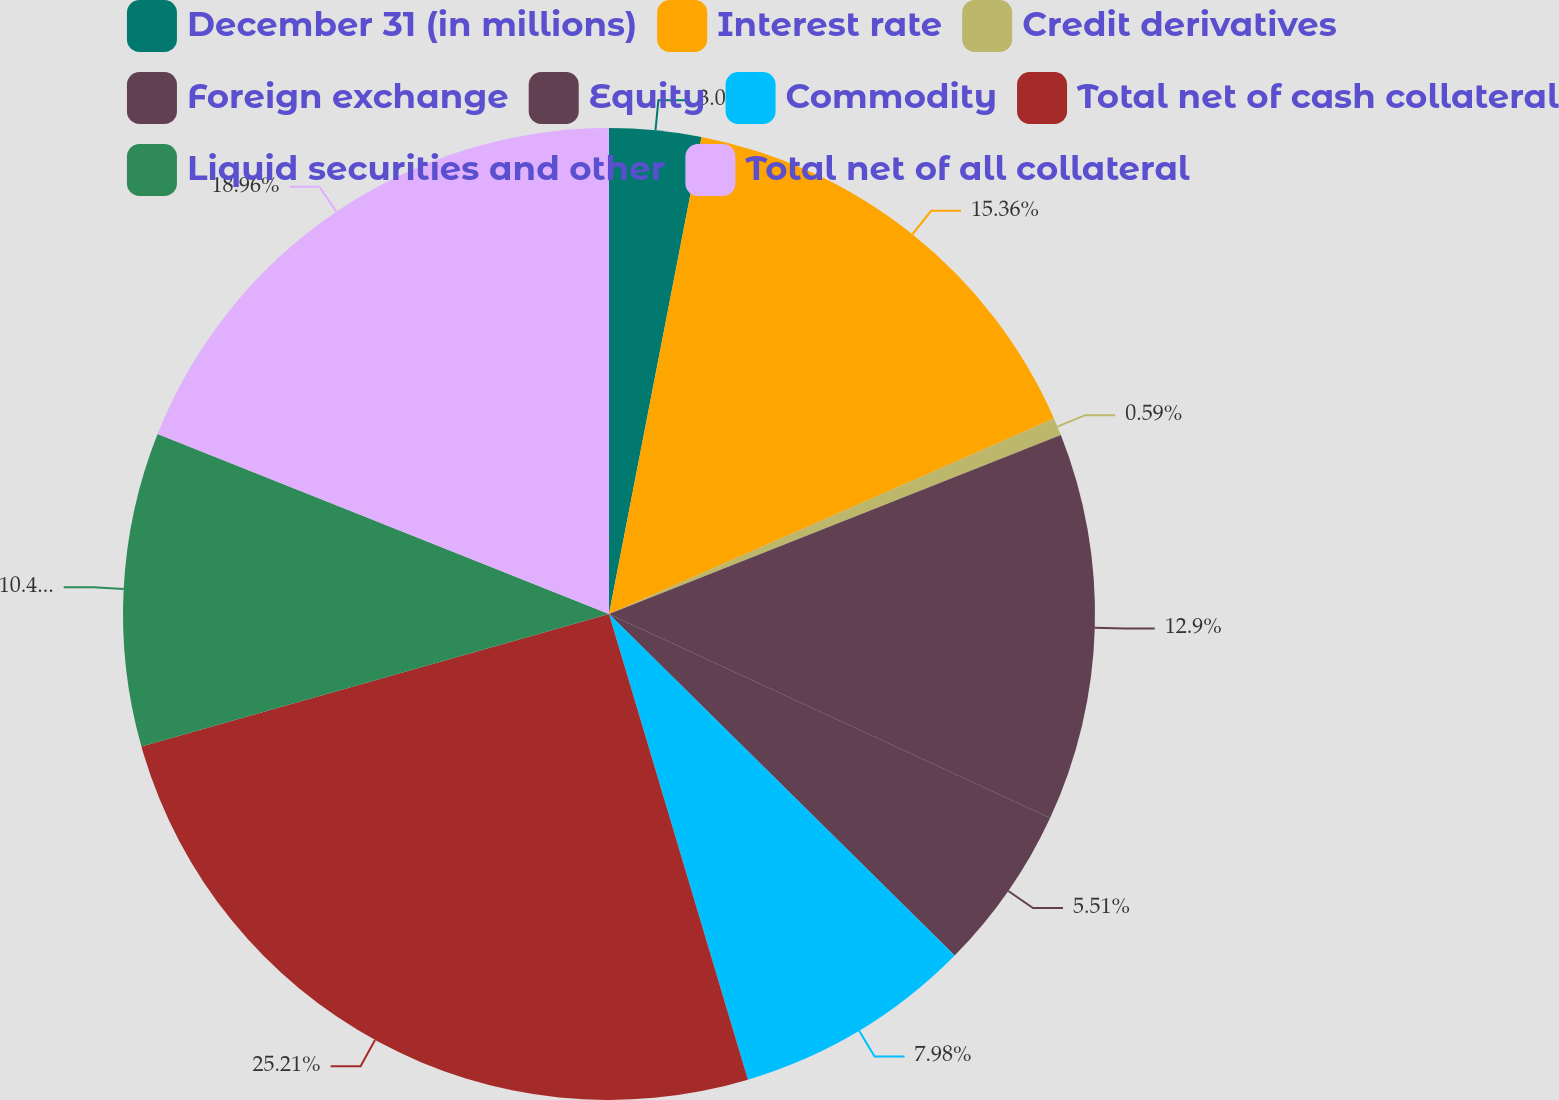Convert chart to OTSL. <chart><loc_0><loc_0><loc_500><loc_500><pie_chart><fcel>December 31 (in millions)<fcel>Interest rate<fcel>Credit derivatives<fcel>Foreign exchange<fcel>Equity<fcel>Commodity<fcel>Total net of cash collateral<fcel>Liquid securities and other<fcel>Total net of all collateral<nl><fcel>3.05%<fcel>15.36%<fcel>0.59%<fcel>12.9%<fcel>5.51%<fcel>7.98%<fcel>25.22%<fcel>10.44%<fcel>18.96%<nl></chart> 